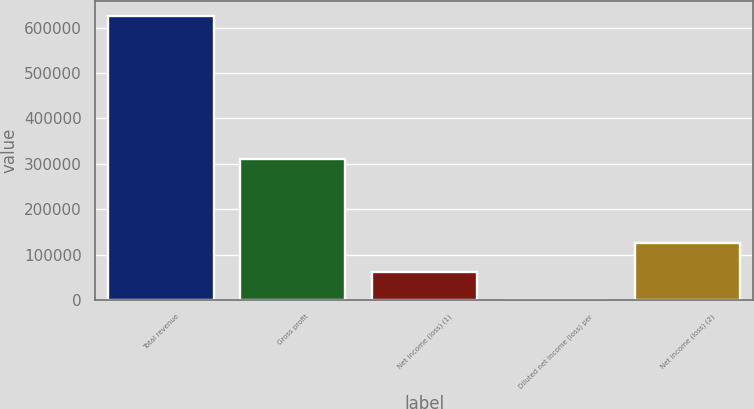Convert chart. <chart><loc_0><loc_0><loc_500><loc_500><bar_chart><fcel>Total revenue<fcel>Gross profit<fcel>Net income (loss) (1)<fcel>Diluted net income (loss) per<fcel>Net income (loss) (2)<nl><fcel>626136<fcel>309758<fcel>62613.6<fcel>0.04<fcel>125227<nl></chart> 